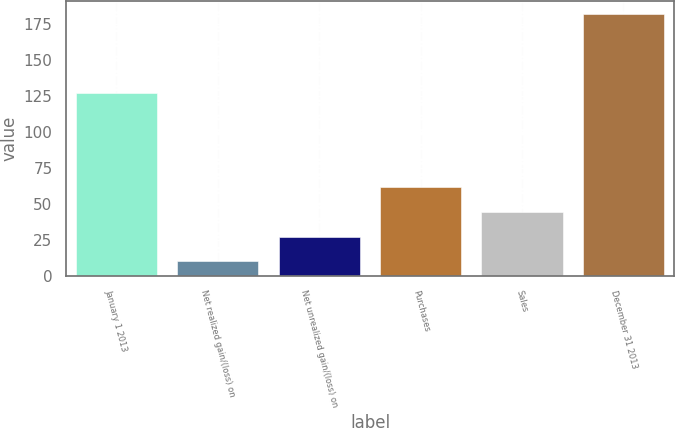Convert chart. <chart><loc_0><loc_0><loc_500><loc_500><bar_chart><fcel>January 1 2013<fcel>Net realized gain/(loss) on<fcel>Net unrealized gain/(loss) on<fcel>Purchases<fcel>Sales<fcel>December 31 2013<nl><fcel>127<fcel>10<fcel>27.2<fcel>61.6<fcel>44.4<fcel>182<nl></chart> 